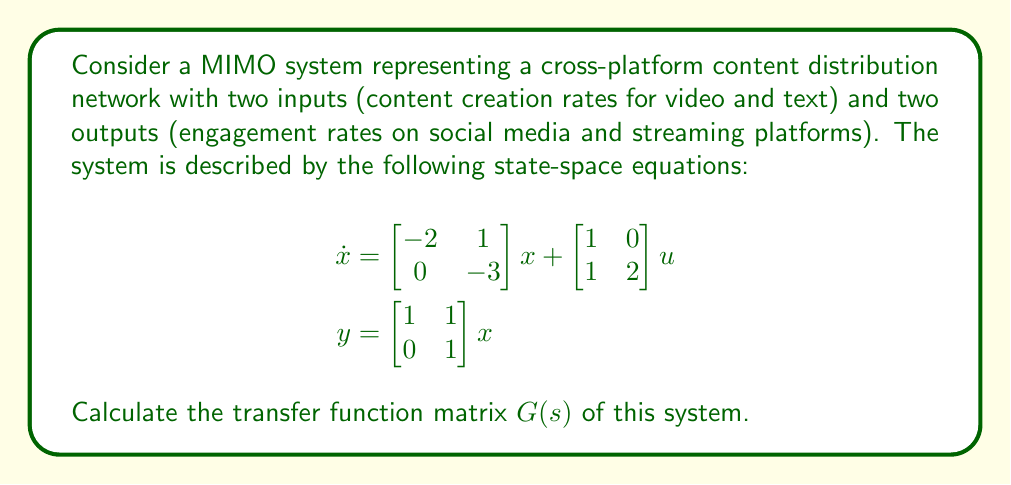Help me with this question. To calculate the transfer function matrix of a MIMO system using state-space representation, we'll follow these steps:

1) The general form of a state-space representation is:
   $$\begin{aligned}
   \dot{x} &= Ax + Bu \\
   y &= Cx + Du
   \end{aligned}$$

   Where in our case:
   $$A = \begin{bmatrix} -2 & 1 \\ 0 & -3 \end{bmatrix}, 
   B = \begin{bmatrix} 1 & 0 \\ 1 & 2 \end{bmatrix}, 
   C = \begin{bmatrix} 1 & 1 \\ 0 & 1 \end{bmatrix}, 
   D = \begin{bmatrix} 0 & 0 \\ 0 & 0 \end{bmatrix}$$

2) The transfer function matrix $G(s)$ is given by:
   $$G(s) = C(sI - A)^{-1}B + D$$

3) Let's calculate $(sI - A)$:
   $$sI - A = \begin{bmatrix} s & 0 \\ 0 & s \end{bmatrix} - \begin{bmatrix} -2 & 1 \\ 0 & -3 \end{bmatrix} = \begin{bmatrix} s+2 & -1 \\ 0 & s+3 \end{bmatrix}$$

4) Now, we need to find $(sI - A)^{-1}$:
   $$\begin{aligned}
   (sI - A)^{-1} &= \frac{1}{(s+2)(s+3)} \begin{bmatrix} s+3 & 1 \\ 0 & s+2 \end{bmatrix} \\
   &= \begin{bmatrix} \frac{s+3}{(s+2)(s+3)} & \frac{1}{(s+2)(s+3)} \\ 0 & \frac{1}{s+3} \end{bmatrix}
   \end{aligned}$$

5) Now we can calculate $G(s)$:
   $$\begin{aligned}
   G(s) &= C(sI - A)^{-1}B + D \\
   &= \begin{bmatrix} 1 & 1 \\ 0 & 1 \end{bmatrix} \begin{bmatrix} \frac{s+3}{(s+2)(s+3)} & \frac{1}{(s+2)(s+3)} \\ 0 & \frac{1}{s+3} \end{bmatrix} \begin{bmatrix} 1 & 0 \\ 1 & 2 \end{bmatrix} + \begin{bmatrix} 0 & 0 \\ 0 & 0 \end{bmatrix}
   \end{aligned}$$

6) Multiplying these matrices:
   $$\begin{aligned}
   G(s) &= \begin{bmatrix} \frac{s+3}{(s+2)(s+3)} + \frac{1}{(s+2)(s+3)} & \frac{1}{(s+2)(s+3)} + \frac{2}{s+3} \\ \frac{1}{s+3} & \frac{2}{s+3} \end{bmatrix} \\
   &= \begin{bmatrix} \frac{s+4}{(s+2)(s+3)} & \frac{2s+7}{(s+2)(s+3)} \\ \frac{1}{s+3} & \frac{2}{s+3} \end{bmatrix}
   \end{aligned}$$
Answer: The transfer function matrix of the system is:

$$G(s) = \begin{bmatrix} \frac{s+4}{(s+2)(s+3)} & \frac{2s+7}{(s+2)(s+3)} \\ \frac{1}{s+3} & \frac{2}{s+3} \end{bmatrix}$$ 